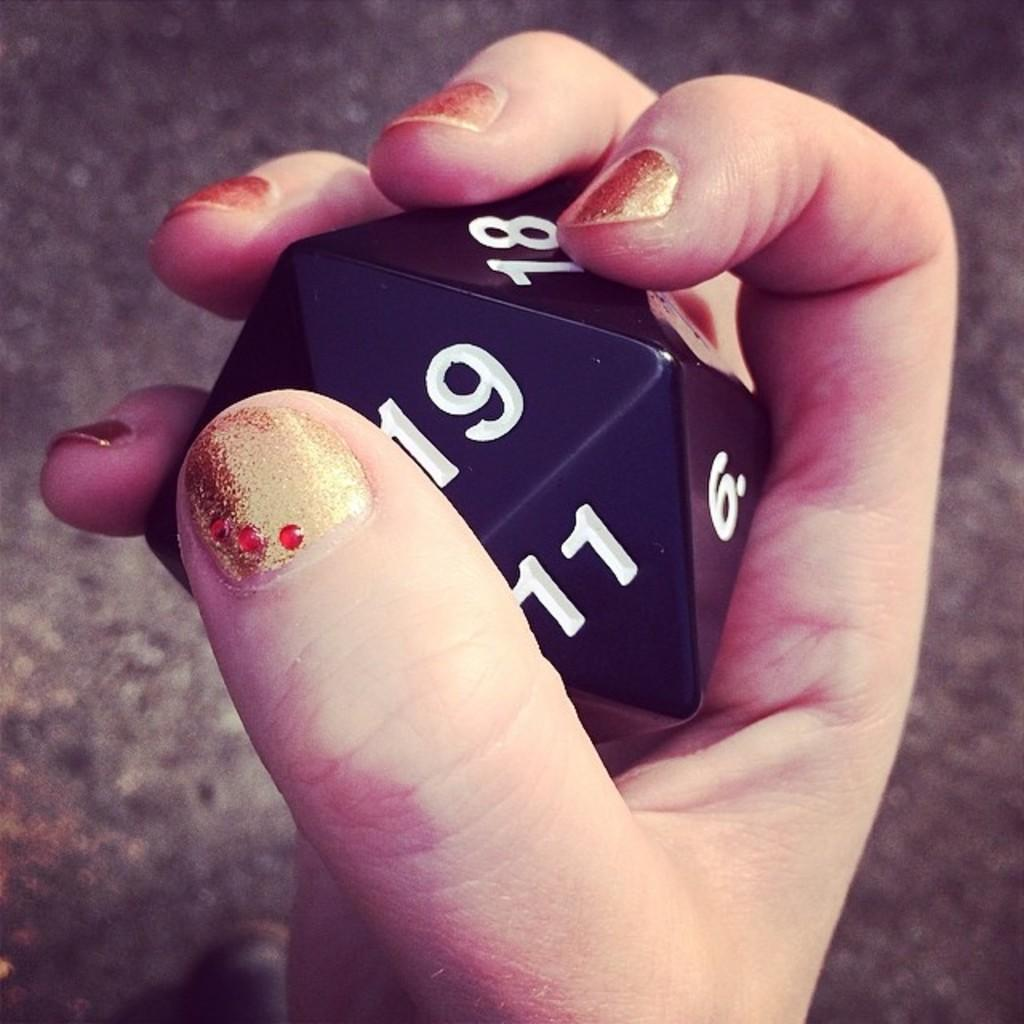What is being held in the person's hand in the image? The hand is holding a dice. What can be observed on the dice? The dice has numbers on it. What is visible in the background of the image? There is a floor visible in the background of the image. What type of joke is being told by the sea in the image? There is no sea present in the image, so it is not possible to determine if a joke is being told. 